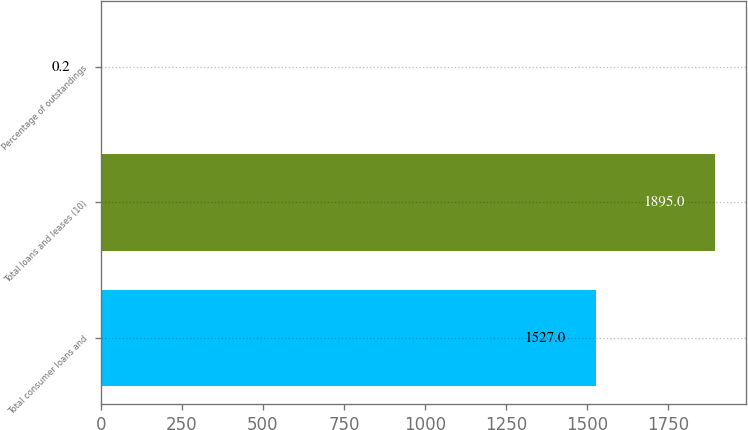<chart> <loc_0><loc_0><loc_500><loc_500><bar_chart><fcel>Total consumer loans and<fcel>Total loans and leases (10)<fcel>Percentage of outstandings<nl><fcel>1527<fcel>1895<fcel>0.2<nl></chart> 